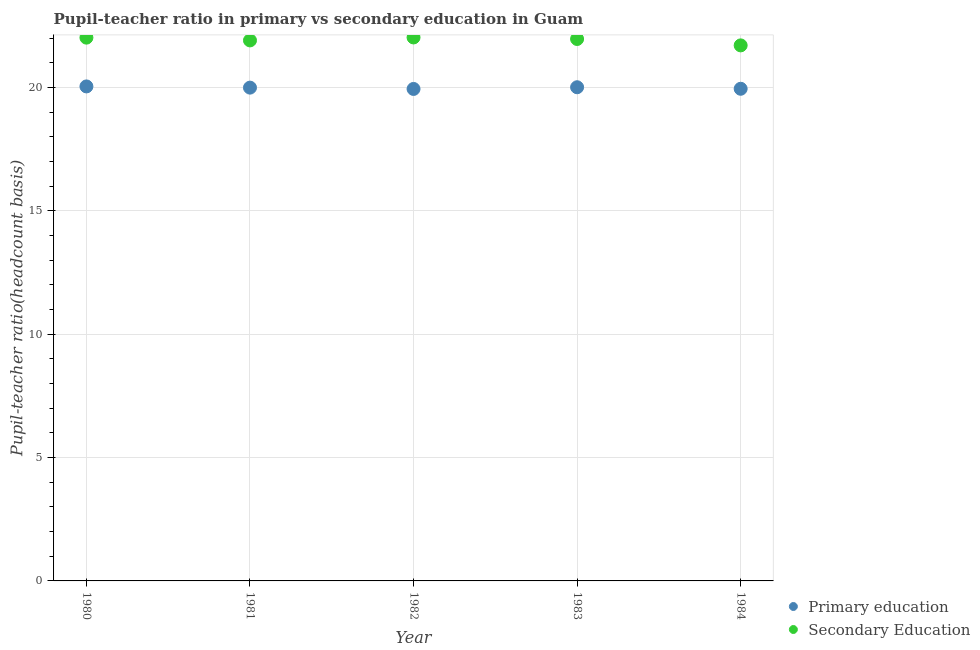What is the pupil-teacher ratio in primary education in 1983?
Your response must be concise. 20.01. Across all years, what is the maximum pupil teacher ratio on secondary education?
Provide a short and direct response. 22.03. Across all years, what is the minimum pupil teacher ratio on secondary education?
Give a very brief answer. 21.7. What is the total pupil-teacher ratio in primary education in the graph?
Keep it short and to the point. 99.93. What is the difference between the pupil-teacher ratio in primary education in 1980 and that in 1984?
Provide a short and direct response. 0.1. What is the difference between the pupil teacher ratio on secondary education in 1982 and the pupil-teacher ratio in primary education in 1981?
Your answer should be very brief. 2.03. What is the average pupil-teacher ratio in primary education per year?
Keep it short and to the point. 19.99. In the year 1980, what is the difference between the pupil teacher ratio on secondary education and pupil-teacher ratio in primary education?
Make the answer very short. 1.98. What is the ratio of the pupil-teacher ratio in primary education in 1982 to that in 1983?
Your answer should be very brief. 1. Is the pupil teacher ratio on secondary education in 1980 less than that in 1981?
Provide a succinct answer. No. What is the difference between the highest and the second highest pupil-teacher ratio in primary education?
Make the answer very short. 0.03. What is the difference between the highest and the lowest pupil teacher ratio on secondary education?
Provide a succinct answer. 0.32. Is the pupil-teacher ratio in primary education strictly greater than the pupil teacher ratio on secondary education over the years?
Give a very brief answer. No. Is the pupil teacher ratio on secondary education strictly less than the pupil-teacher ratio in primary education over the years?
Provide a succinct answer. No. How many dotlines are there?
Offer a very short reply. 2. How many years are there in the graph?
Give a very brief answer. 5. What is the difference between two consecutive major ticks on the Y-axis?
Your answer should be compact. 5. Does the graph contain any zero values?
Make the answer very short. No. Where does the legend appear in the graph?
Ensure brevity in your answer.  Bottom right. How are the legend labels stacked?
Make the answer very short. Vertical. What is the title of the graph?
Offer a very short reply. Pupil-teacher ratio in primary vs secondary education in Guam. Does "Taxes" appear as one of the legend labels in the graph?
Your answer should be very brief. No. What is the label or title of the X-axis?
Give a very brief answer. Year. What is the label or title of the Y-axis?
Make the answer very short. Pupil-teacher ratio(headcount basis). What is the Pupil-teacher ratio(headcount basis) of Primary education in 1980?
Your response must be concise. 20.04. What is the Pupil-teacher ratio(headcount basis) in Secondary Education in 1980?
Offer a terse response. 22.02. What is the Pupil-teacher ratio(headcount basis) in Primary education in 1981?
Your answer should be compact. 19.99. What is the Pupil-teacher ratio(headcount basis) in Secondary Education in 1981?
Ensure brevity in your answer.  21.91. What is the Pupil-teacher ratio(headcount basis) in Primary education in 1982?
Offer a very short reply. 19.94. What is the Pupil-teacher ratio(headcount basis) in Secondary Education in 1982?
Your answer should be very brief. 22.03. What is the Pupil-teacher ratio(headcount basis) of Primary education in 1983?
Make the answer very short. 20.01. What is the Pupil-teacher ratio(headcount basis) in Secondary Education in 1983?
Your answer should be very brief. 21.96. What is the Pupil-teacher ratio(headcount basis) in Primary education in 1984?
Keep it short and to the point. 19.95. What is the Pupil-teacher ratio(headcount basis) in Secondary Education in 1984?
Provide a short and direct response. 21.7. Across all years, what is the maximum Pupil-teacher ratio(headcount basis) of Primary education?
Offer a terse response. 20.04. Across all years, what is the maximum Pupil-teacher ratio(headcount basis) of Secondary Education?
Keep it short and to the point. 22.03. Across all years, what is the minimum Pupil-teacher ratio(headcount basis) in Primary education?
Your answer should be very brief. 19.94. Across all years, what is the minimum Pupil-teacher ratio(headcount basis) in Secondary Education?
Offer a very short reply. 21.7. What is the total Pupil-teacher ratio(headcount basis) in Primary education in the graph?
Give a very brief answer. 99.93. What is the total Pupil-teacher ratio(headcount basis) in Secondary Education in the graph?
Keep it short and to the point. 109.62. What is the difference between the Pupil-teacher ratio(headcount basis) of Primary education in 1980 and that in 1981?
Provide a short and direct response. 0.05. What is the difference between the Pupil-teacher ratio(headcount basis) in Secondary Education in 1980 and that in 1981?
Offer a terse response. 0.11. What is the difference between the Pupil-teacher ratio(headcount basis) in Primary education in 1980 and that in 1982?
Make the answer very short. 0.1. What is the difference between the Pupil-teacher ratio(headcount basis) of Secondary Education in 1980 and that in 1982?
Your response must be concise. -0.01. What is the difference between the Pupil-teacher ratio(headcount basis) in Primary education in 1980 and that in 1983?
Give a very brief answer. 0.03. What is the difference between the Pupil-teacher ratio(headcount basis) of Secondary Education in 1980 and that in 1983?
Your response must be concise. 0.06. What is the difference between the Pupil-teacher ratio(headcount basis) of Primary education in 1980 and that in 1984?
Make the answer very short. 0.1. What is the difference between the Pupil-teacher ratio(headcount basis) of Secondary Education in 1980 and that in 1984?
Make the answer very short. 0.31. What is the difference between the Pupil-teacher ratio(headcount basis) of Primary education in 1981 and that in 1982?
Provide a succinct answer. 0.05. What is the difference between the Pupil-teacher ratio(headcount basis) of Secondary Education in 1981 and that in 1982?
Give a very brief answer. -0.12. What is the difference between the Pupil-teacher ratio(headcount basis) in Primary education in 1981 and that in 1983?
Your answer should be compact. -0.02. What is the difference between the Pupil-teacher ratio(headcount basis) of Secondary Education in 1981 and that in 1983?
Your answer should be very brief. -0.06. What is the difference between the Pupil-teacher ratio(headcount basis) in Primary education in 1981 and that in 1984?
Give a very brief answer. 0.05. What is the difference between the Pupil-teacher ratio(headcount basis) of Secondary Education in 1981 and that in 1984?
Your answer should be compact. 0.2. What is the difference between the Pupil-teacher ratio(headcount basis) of Primary education in 1982 and that in 1983?
Offer a very short reply. -0.07. What is the difference between the Pupil-teacher ratio(headcount basis) in Secondary Education in 1982 and that in 1983?
Give a very brief answer. 0.06. What is the difference between the Pupil-teacher ratio(headcount basis) in Primary education in 1982 and that in 1984?
Offer a terse response. -0.01. What is the difference between the Pupil-teacher ratio(headcount basis) of Secondary Education in 1982 and that in 1984?
Provide a succinct answer. 0.32. What is the difference between the Pupil-teacher ratio(headcount basis) in Primary education in 1983 and that in 1984?
Provide a succinct answer. 0.06. What is the difference between the Pupil-teacher ratio(headcount basis) in Secondary Education in 1983 and that in 1984?
Give a very brief answer. 0.26. What is the difference between the Pupil-teacher ratio(headcount basis) in Primary education in 1980 and the Pupil-teacher ratio(headcount basis) in Secondary Education in 1981?
Your answer should be compact. -1.86. What is the difference between the Pupil-teacher ratio(headcount basis) of Primary education in 1980 and the Pupil-teacher ratio(headcount basis) of Secondary Education in 1982?
Offer a very short reply. -1.98. What is the difference between the Pupil-teacher ratio(headcount basis) of Primary education in 1980 and the Pupil-teacher ratio(headcount basis) of Secondary Education in 1983?
Your answer should be compact. -1.92. What is the difference between the Pupil-teacher ratio(headcount basis) of Primary education in 1980 and the Pupil-teacher ratio(headcount basis) of Secondary Education in 1984?
Provide a succinct answer. -1.66. What is the difference between the Pupil-teacher ratio(headcount basis) in Primary education in 1981 and the Pupil-teacher ratio(headcount basis) in Secondary Education in 1982?
Make the answer very short. -2.03. What is the difference between the Pupil-teacher ratio(headcount basis) of Primary education in 1981 and the Pupil-teacher ratio(headcount basis) of Secondary Education in 1983?
Your answer should be very brief. -1.97. What is the difference between the Pupil-teacher ratio(headcount basis) of Primary education in 1981 and the Pupil-teacher ratio(headcount basis) of Secondary Education in 1984?
Keep it short and to the point. -1.71. What is the difference between the Pupil-teacher ratio(headcount basis) of Primary education in 1982 and the Pupil-teacher ratio(headcount basis) of Secondary Education in 1983?
Keep it short and to the point. -2.02. What is the difference between the Pupil-teacher ratio(headcount basis) in Primary education in 1982 and the Pupil-teacher ratio(headcount basis) in Secondary Education in 1984?
Your answer should be very brief. -1.77. What is the difference between the Pupil-teacher ratio(headcount basis) of Primary education in 1983 and the Pupil-teacher ratio(headcount basis) of Secondary Education in 1984?
Your answer should be very brief. -1.7. What is the average Pupil-teacher ratio(headcount basis) of Primary education per year?
Offer a very short reply. 19.99. What is the average Pupil-teacher ratio(headcount basis) of Secondary Education per year?
Offer a very short reply. 21.92. In the year 1980, what is the difference between the Pupil-teacher ratio(headcount basis) of Primary education and Pupil-teacher ratio(headcount basis) of Secondary Education?
Your answer should be compact. -1.98. In the year 1981, what is the difference between the Pupil-teacher ratio(headcount basis) of Primary education and Pupil-teacher ratio(headcount basis) of Secondary Education?
Keep it short and to the point. -1.91. In the year 1982, what is the difference between the Pupil-teacher ratio(headcount basis) in Primary education and Pupil-teacher ratio(headcount basis) in Secondary Education?
Make the answer very short. -2.09. In the year 1983, what is the difference between the Pupil-teacher ratio(headcount basis) of Primary education and Pupil-teacher ratio(headcount basis) of Secondary Education?
Ensure brevity in your answer.  -1.96. In the year 1984, what is the difference between the Pupil-teacher ratio(headcount basis) in Primary education and Pupil-teacher ratio(headcount basis) in Secondary Education?
Give a very brief answer. -1.76. What is the ratio of the Pupil-teacher ratio(headcount basis) of Secondary Education in 1980 to that in 1982?
Offer a very short reply. 1. What is the ratio of the Pupil-teacher ratio(headcount basis) in Secondary Education in 1980 to that in 1984?
Make the answer very short. 1.01. What is the ratio of the Pupil-teacher ratio(headcount basis) in Secondary Education in 1981 to that in 1983?
Your response must be concise. 1. What is the ratio of the Pupil-teacher ratio(headcount basis) of Secondary Education in 1981 to that in 1984?
Ensure brevity in your answer.  1.01. What is the ratio of the Pupil-teacher ratio(headcount basis) of Primary education in 1982 to that in 1983?
Your answer should be compact. 1. What is the ratio of the Pupil-teacher ratio(headcount basis) of Secondary Education in 1982 to that in 1984?
Offer a very short reply. 1.01. What is the ratio of the Pupil-teacher ratio(headcount basis) of Primary education in 1983 to that in 1984?
Ensure brevity in your answer.  1. What is the ratio of the Pupil-teacher ratio(headcount basis) in Secondary Education in 1983 to that in 1984?
Provide a short and direct response. 1.01. What is the difference between the highest and the second highest Pupil-teacher ratio(headcount basis) of Primary education?
Offer a terse response. 0.03. What is the difference between the highest and the second highest Pupil-teacher ratio(headcount basis) in Secondary Education?
Offer a terse response. 0.01. What is the difference between the highest and the lowest Pupil-teacher ratio(headcount basis) of Primary education?
Give a very brief answer. 0.1. What is the difference between the highest and the lowest Pupil-teacher ratio(headcount basis) in Secondary Education?
Give a very brief answer. 0.32. 